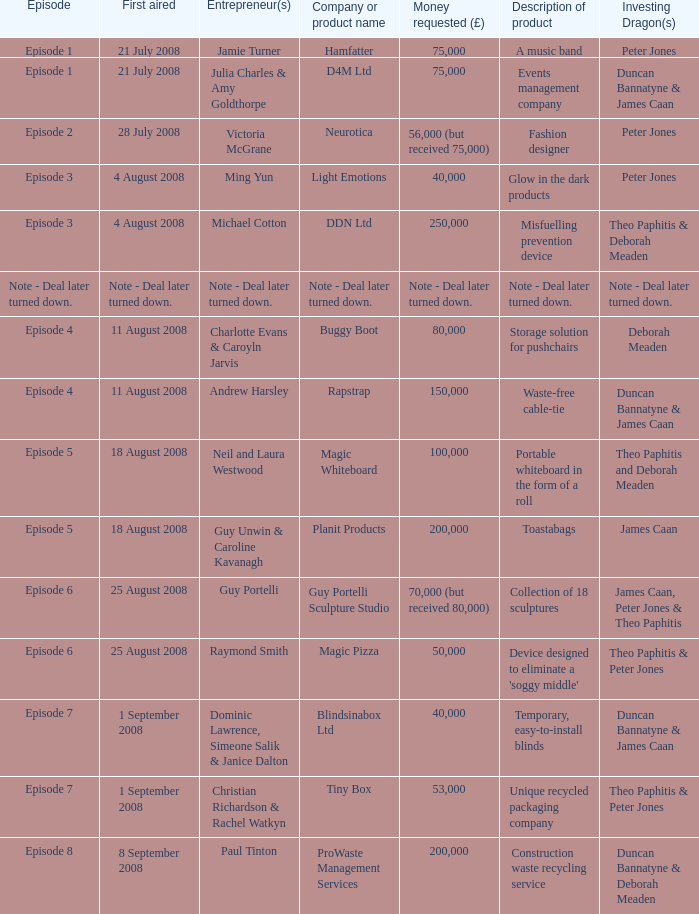How much money did the company Neurotica request? 56,000 (but received 75,000). 